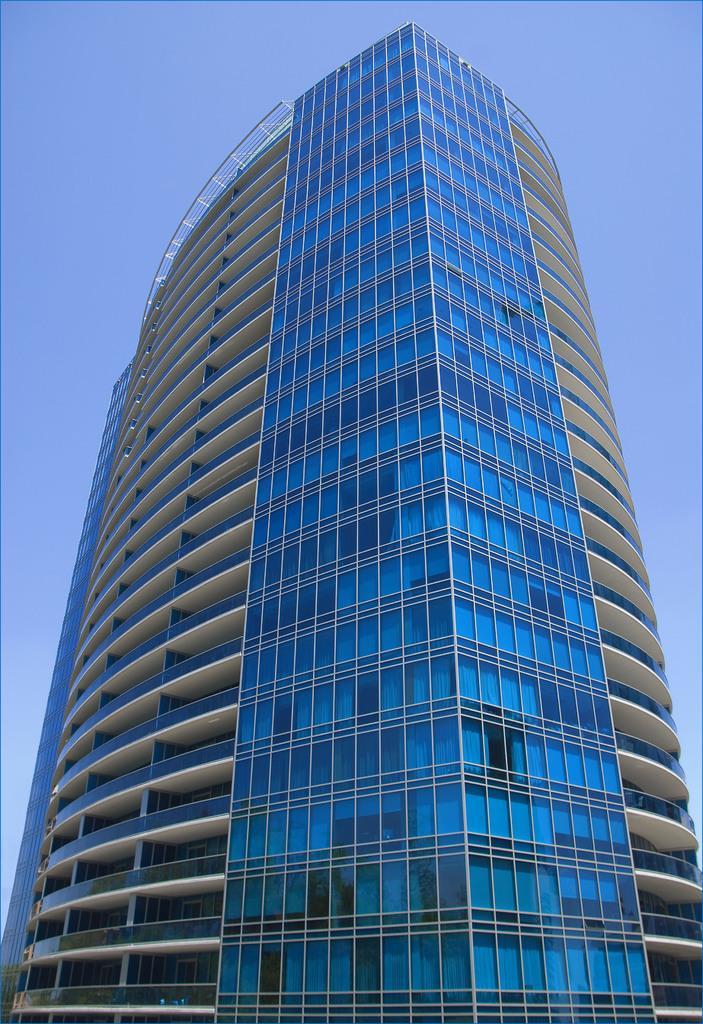In one or two sentences, can you explain what this image depicts? In this image there is a building and back side of building there is the sky visible. 